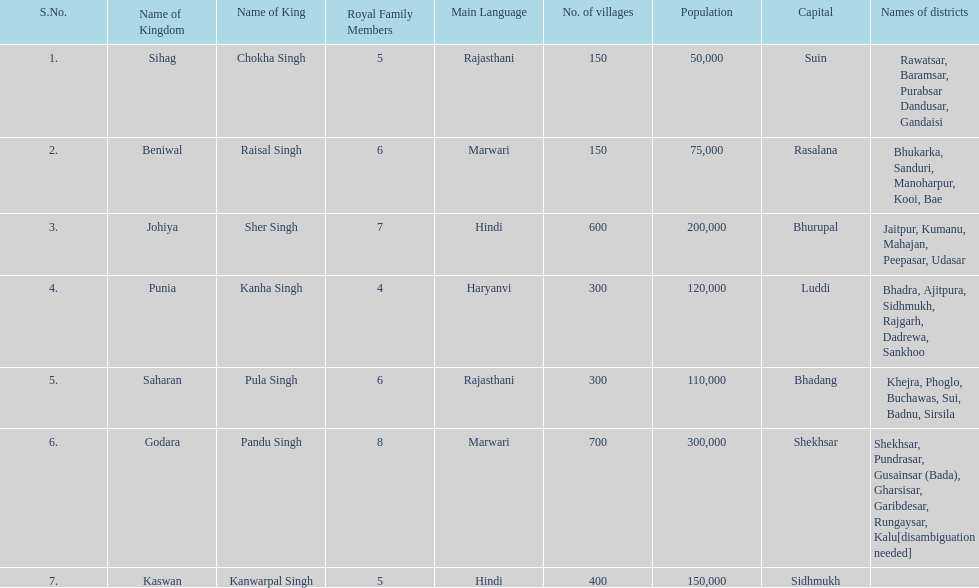He was the king of the sihag kingdom. Chokha Singh. 